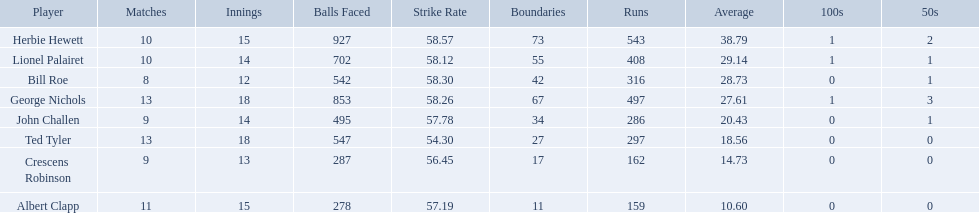Who are the players in somerset county cricket club in 1890? Herbie Hewett, Lionel Palairet, Bill Roe, George Nichols, John Challen, Ted Tyler, Crescens Robinson, Albert Clapp. Who is the only player to play less than 13 innings? Bill Roe. Which players played in 10 or fewer matches? Herbie Hewett, Lionel Palairet, Bill Roe, John Challen, Crescens Robinson. Of these, which played in only 12 innings? Bill Roe. 